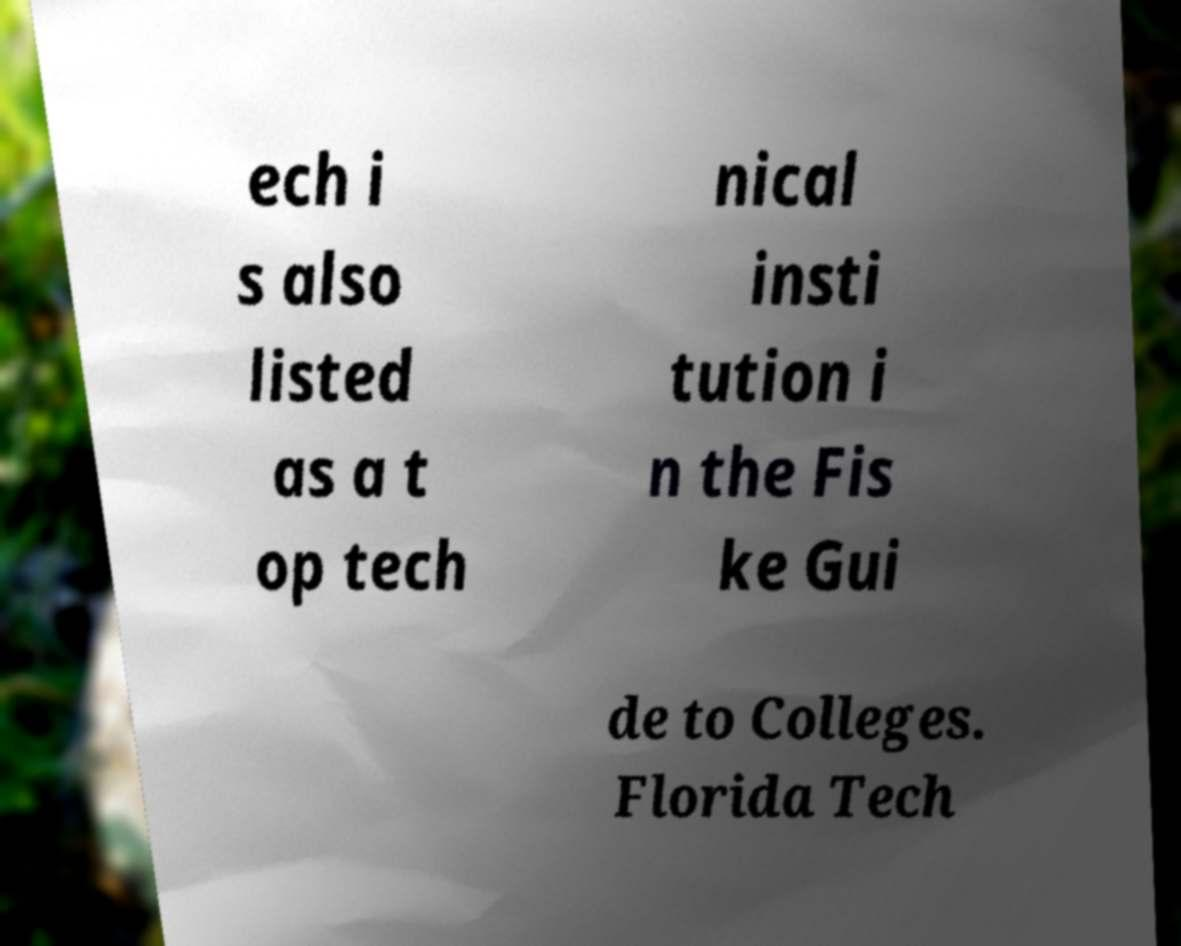There's text embedded in this image that I need extracted. Can you transcribe it verbatim? ech i s also listed as a t op tech nical insti tution i n the Fis ke Gui de to Colleges. Florida Tech 